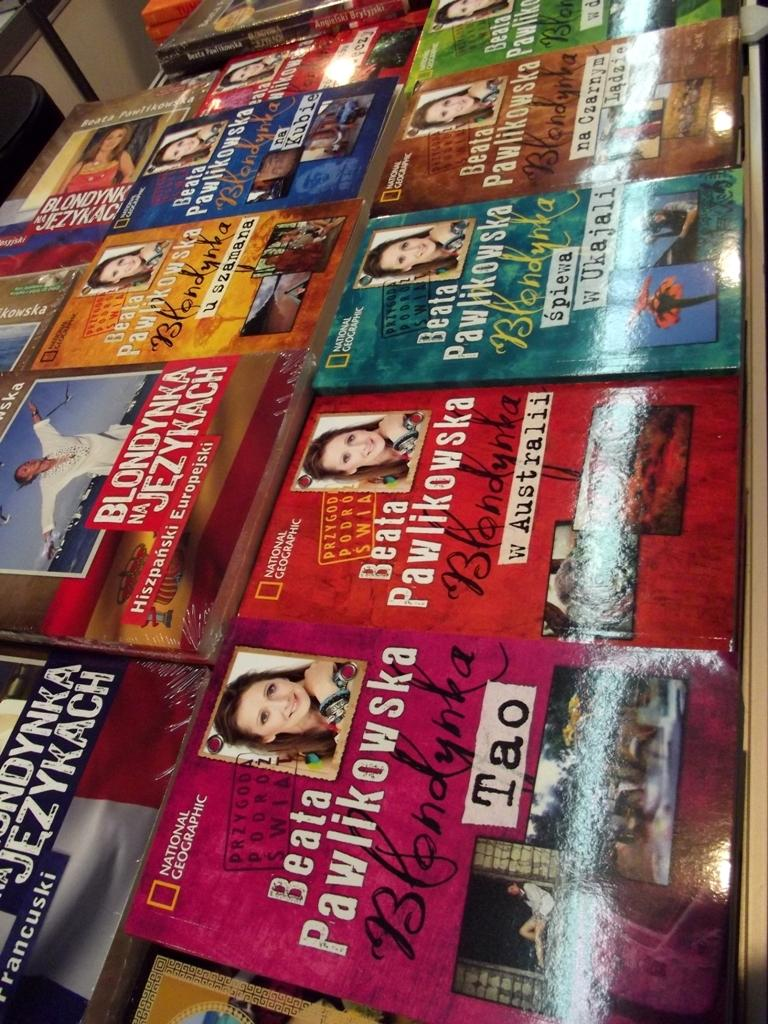<image>
Summarize the visual content of the image. A variety of National Geographic books by Beata Pawikowska and other authors. 